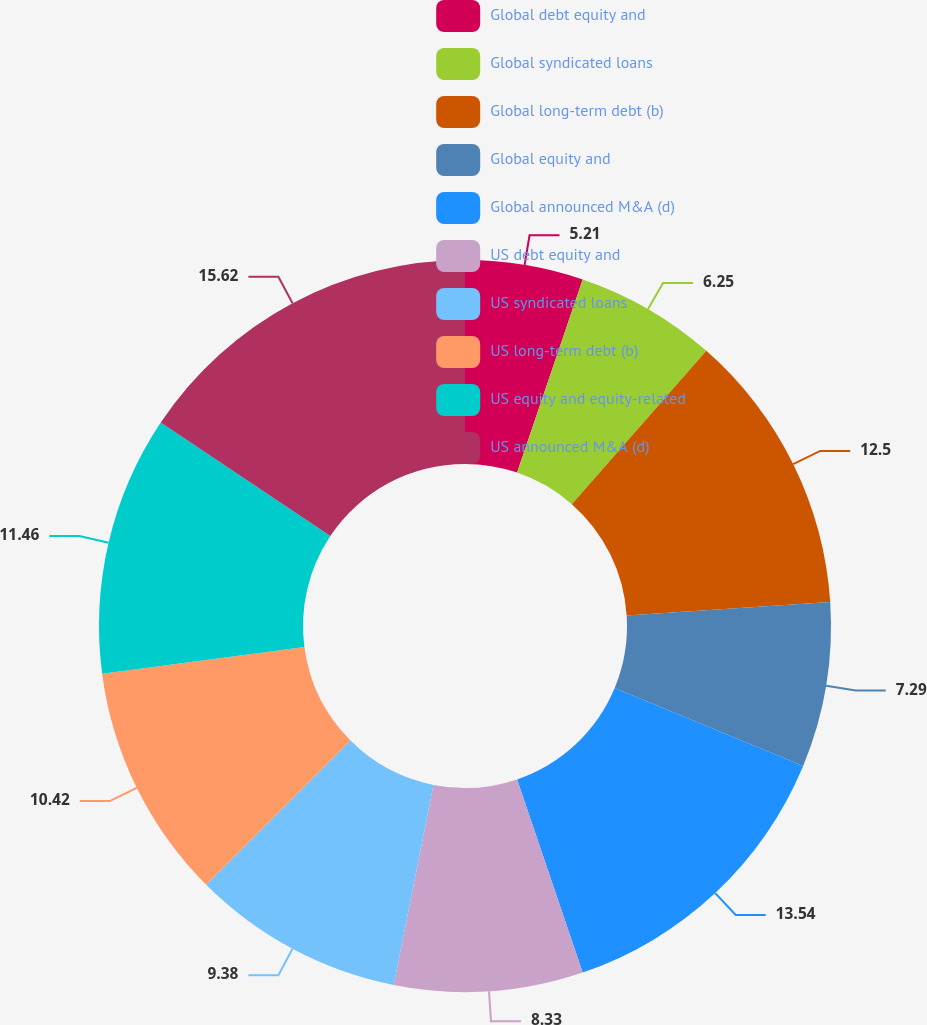Convert chart to OTSL. <chart><loc_0><loc_0><loc_500><loc_500><pie_chart><fcel>Global debt equity and<fcel>Global syndicated loans<fcel>Global long-term debt (b)<fcel>Global equity and<fcel>Global announced M&A (d)<fcel>US debt equity and<fcel>US syndicated loans<fcel>US long-term debt (b)<fcel>US equity and equity-related<fcel>US announced M&A (d)<nl><fcel>5.21%<fcel>6.25%<fcel>12.5%<fcel>7.29%<fcel>13.54%<fcel>8.33%<fcel>9.38%<fcel>10.42%<fcel>11.46%<fcel>15.62%<nl></chart> 